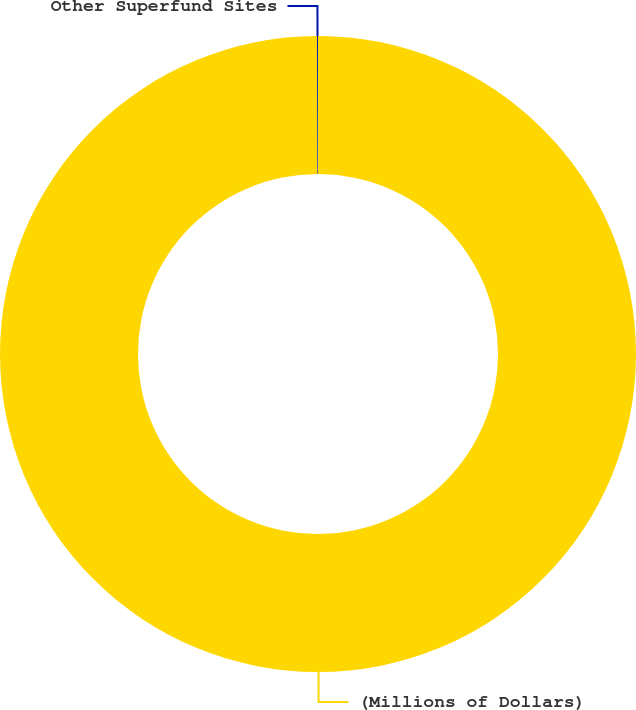Convert chart. <chart><loc_0><loc_0><loc_500><loc_500><pie_chart><fcel>(Millions of Dollars)<fcel>Other Superfund Sites<nl><fcel>99.95%<fcel>0.05%<nl></chart> 